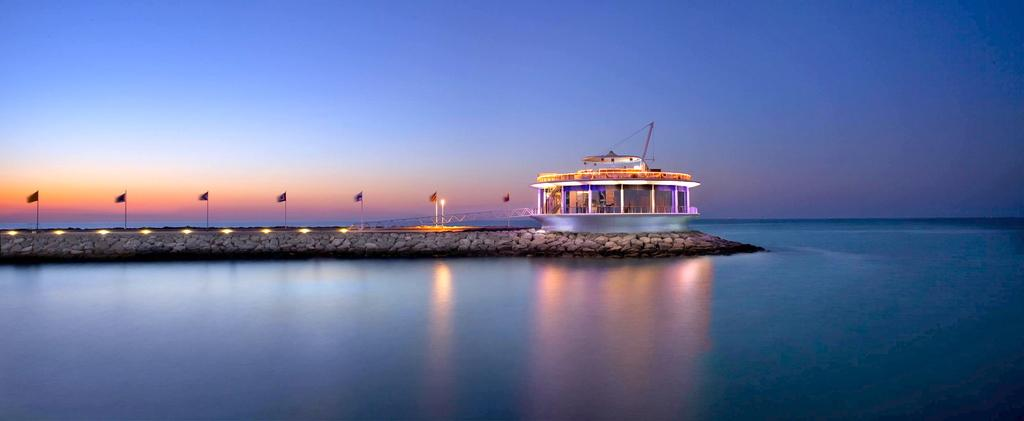What is the primary element visible in the image? There is water in the image. What can be seen besides the water? There is a path in the image, which has lights on it and flags along its side. Is there any structure near the path? Yes, there is a building near the path. What is visible in the background of the image? The sky is visible in the background of the image. What type of sofa can be seen in the image? There is no sofa present in the image. What act of kindness is being performed by the flags in the image? The flags in the image are not performing any act of kindness; they are simply decorative elements along the path. 